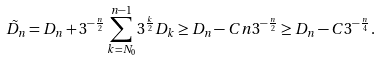<formula> <loc_0><loc_0><loc_500><loc_500>\tilde { D } _ { n } = D _ { n } + 3 ^ { - \frac { n } { 2 } } \sum _ { k = N _ { 0 } } ^ { n - 1 } 3 ^ { \frac { k } { 2 } } D _ { k } \geq D _ { n } - C n 3 ^ { - \frac { n } { 2 } } \geq D _ { n } - C 3 ^ { - \frac { n } { 4 } } .</formula> 